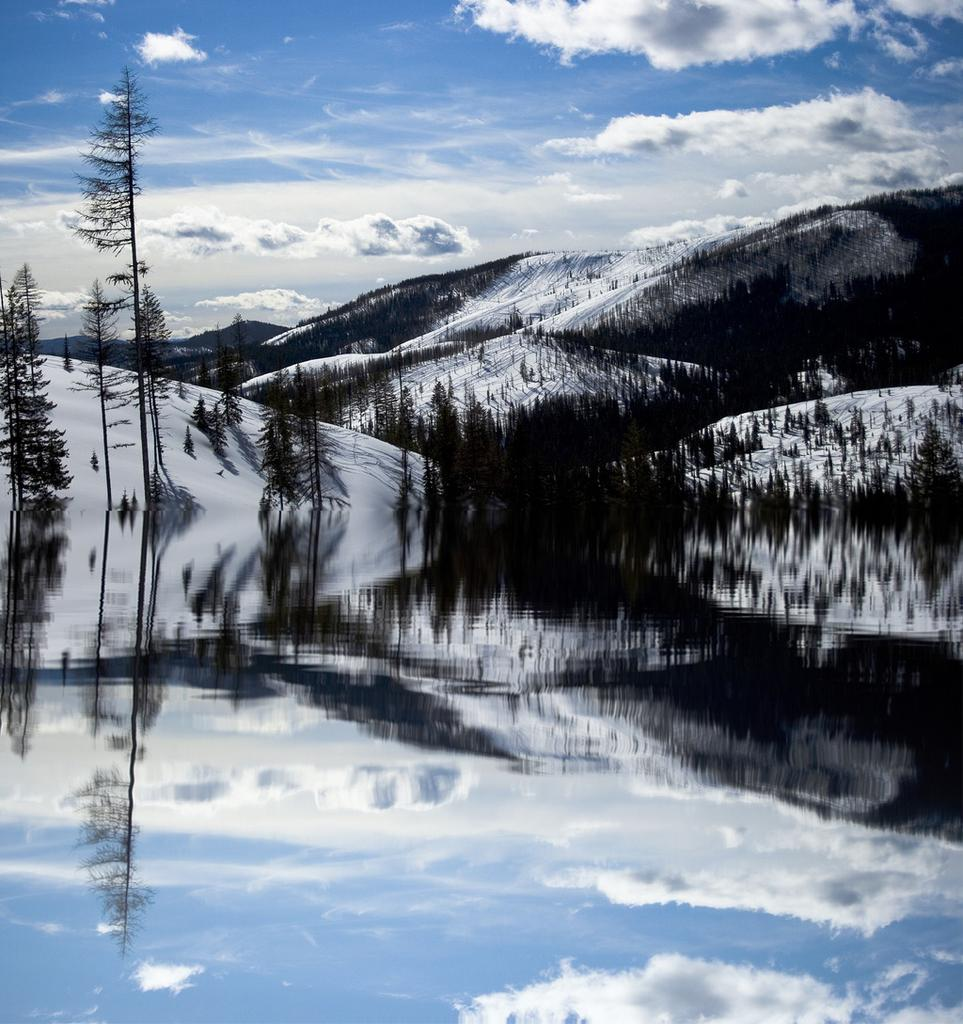What type of natural feature is present in the image? There is a river in the image. Can you describe the river in the image? The river water is visible in the image. What can be seen in the background of the image? There is a snow mountain and many trees in the background of the image. What type of jewel is the man wearing on his sock in the image? There is no man or jewel present in the image; it features a river, snow mountain, and trees in the background. 